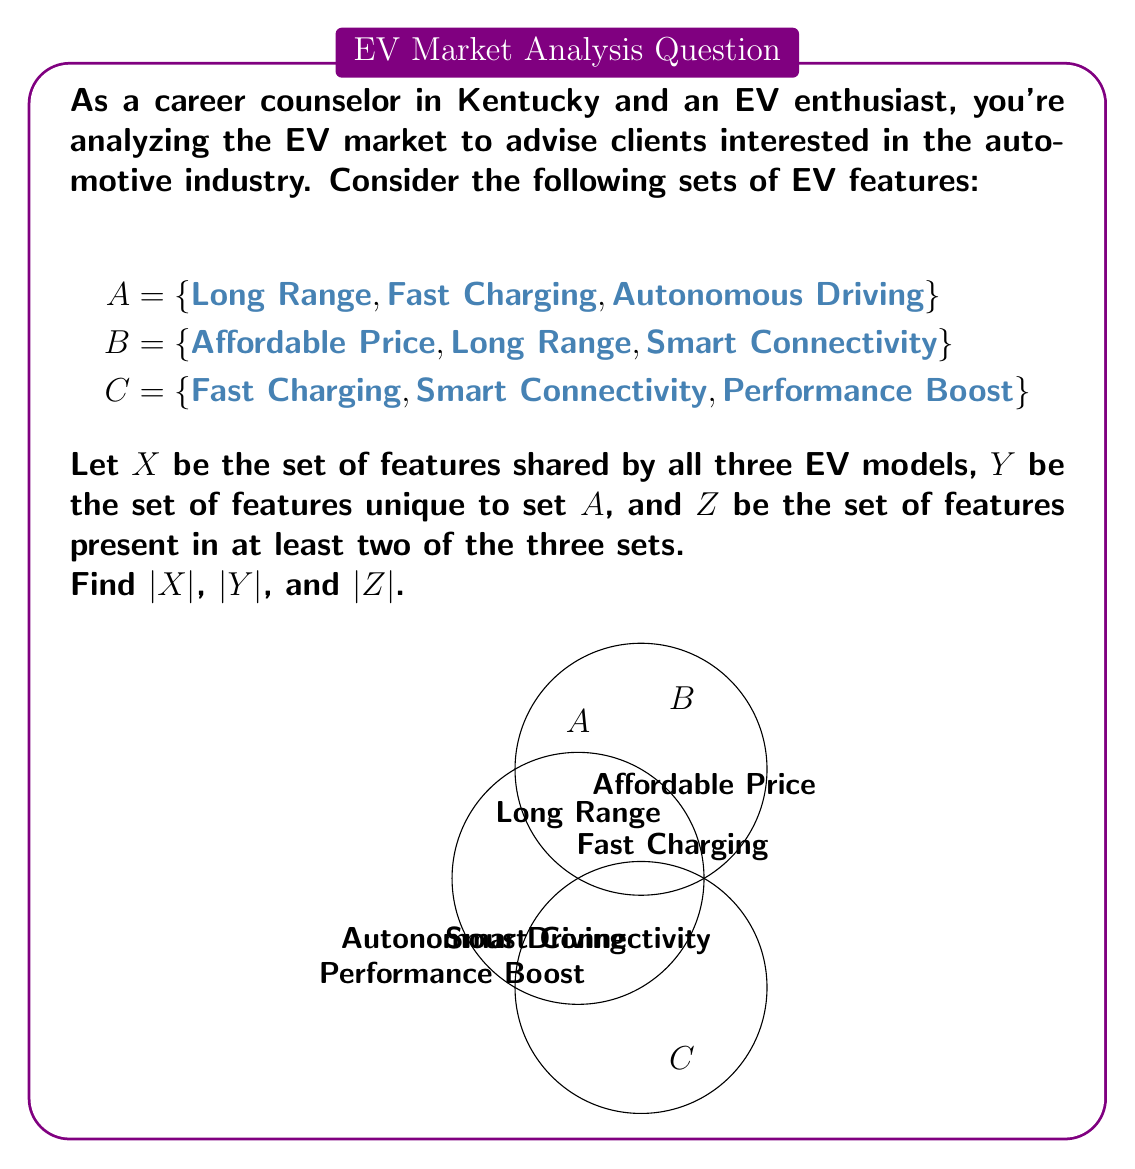Can you solve this math problem? Let's approach this step-by-step:

1) First, let's identify the elements in each set:
   X = A ∩ B ∩ C (features shared by all three sets)
   Y = A - (B ∪ C) (features unique to set A)
   Z = (A ∩ B) ∪ (B ∩ C) ∪ (A ∩ C) (features in at least two sets)

2) To find X:
   X = A ∩ B ∩ C = {Fast Charging}
   Therefore, $|X| = 1$

3) To find Y:
   Y = A - (B ∪ C) = {Autonomous Driving}
   Therefore, $|Y| = 1$

4) To find Z:
   A ∩ B = {Long Range}
   B ∩ C = {Smart Connectivity}
   A ∩ C = {Fast Charging}
   Z = (A ∩ B) ∪ (B ∩ C) ∪ (A ∩ C) = {Long Range, Smart Connectivity, Fast Charging}
   Therefore, $|Z| = 3$
Answer: $|X| = 1$, $|Y| = 1$, $|Z| = 3$ 